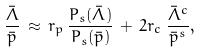<formula> <loc_0><loc_0><loc_500><loc_500>\frac { \bar { \Lambda } } { \bar { p } } \, \approx \, r _ { p } \, \frac { P _ { s } ( { \bar { \Lambda } } ) } { P _ { s } ( { \bar { p } } ) } \, + \, 2 r _ { c } \, \frac { { \bar { \Lambda } } ^ { c } } { { \bar { p } } ^ { s } } ,</formula> 